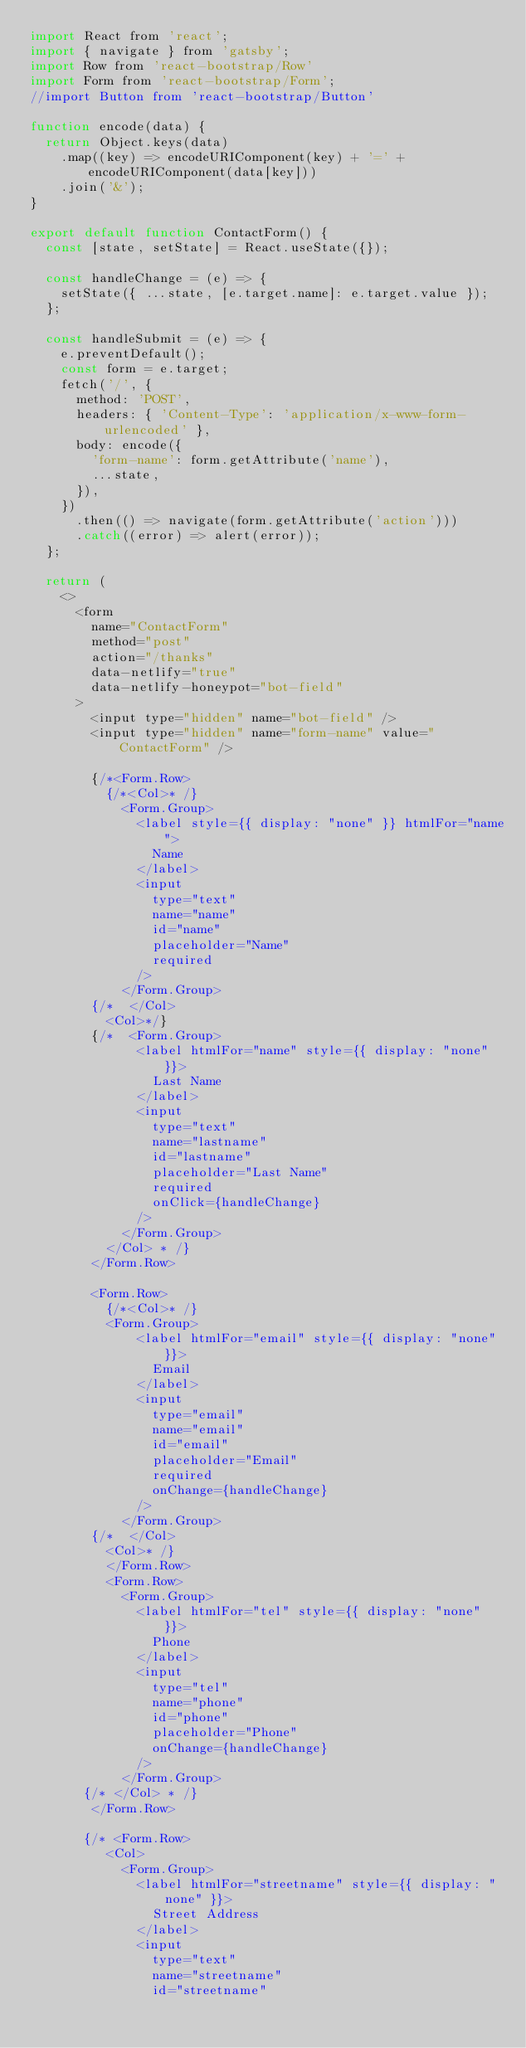<code> <loc_0><loc_0><loc_500><loc_500><_JavaScript_>import React from 'react';
import { navigate } from 'gatsby';
import Row from 'react-bootstrap/Row'
import Form from 'react-bootstrap/Form';
//import Button from 'react-bootstrap/Button'

function encode(data) {
  return Object.keys(data)
    .map((key) => encodeURIComponent(key) + '=' + encodeURIComponent(data[key]))
    .join('&');
}

export default function ContactForm() {
  const [state, setState] = React.useState({});

  const handleChange = (e) => {
    setState({ ...state, [e.target.name]: e.target.value });
  };

  const handleSubmit = (e) => {
    e.preventDefault();
    const form = e.target;
    fetch('/', {
      method: 'POST',
      headers: { 'Content-Type': 'application/x-www-form-urlencoded' },
      body: encode({
        'form-name': form.getAttribute('name'),
        ...state,
      }),
    })
      .then(() => navigate(form.getAttribute('action')))
      .catch((error) => alert(error));
  };

  return (
    <>
      <form
        name="ContactForm"
        method="post"
        action="/thanks"
        data-netlify="true"
        data-netlify-honeypot="bot-field"
      >
        <input type="hidden" name="bot-field" />
        <input type="hidden" name="form-name" value="ContactForm" />

        {/*<Form.Row>
          {/*<Col>* /}
            <Form.Group>
              <label style={{ display: "none" }} htmlFor="name">
                Name
              </label>
              <input
                type="text"
                name="name"
                id="name"
                placeholder="Name"
                required
              />
            </Form.Group>
        {/*  </Col> 
          <Col>*/}
        {/*  <Form.Group>
              <label htmlFor="name" style={{ display: "none" }}>
                Last Name
              </label>
              <input
                type="text"
                name="lastname"
                id="lastname"
                placeholder="Last Name"
                required
                onClick={handleChange}
              />
            </Form.Group>
          </Col> * /}
        </Form.Row>

        <Form.Row>
          {/*<Col>* /}
          <Form.Group>
              <label htmlFor="email" style={{ display: "none" }}>
                Email
              </label>
              <input
                type="email"
                name="email"
                id="email"
                placeholder="Email"
                required
                onChange={handleChange}
              />
            </Form.Group>
        {/*  </Col> 
          <Col>* /}
          </Form.Row>
          <Form.Row>
            <Form.Group>
              <label htmlFor="tel" style={{ display: "none" }}>
                Phone
              </label>
              <input
                type="tel"
                name="phone"
                id="phone"
                placeholder="Phone"
                onChange={handleChange}
              />
            </Form.Group>
       {/* </Col> * /}
        </Form.Row>

       {/* <Form.Row>
          <Col>
            <Form.Group>
              <label htmlFor="streetname" style={{ display: "none" }}>
                Street Address
              </label>
              <input
                type="text"
                name="streetname"
                id="streetname"</code> 